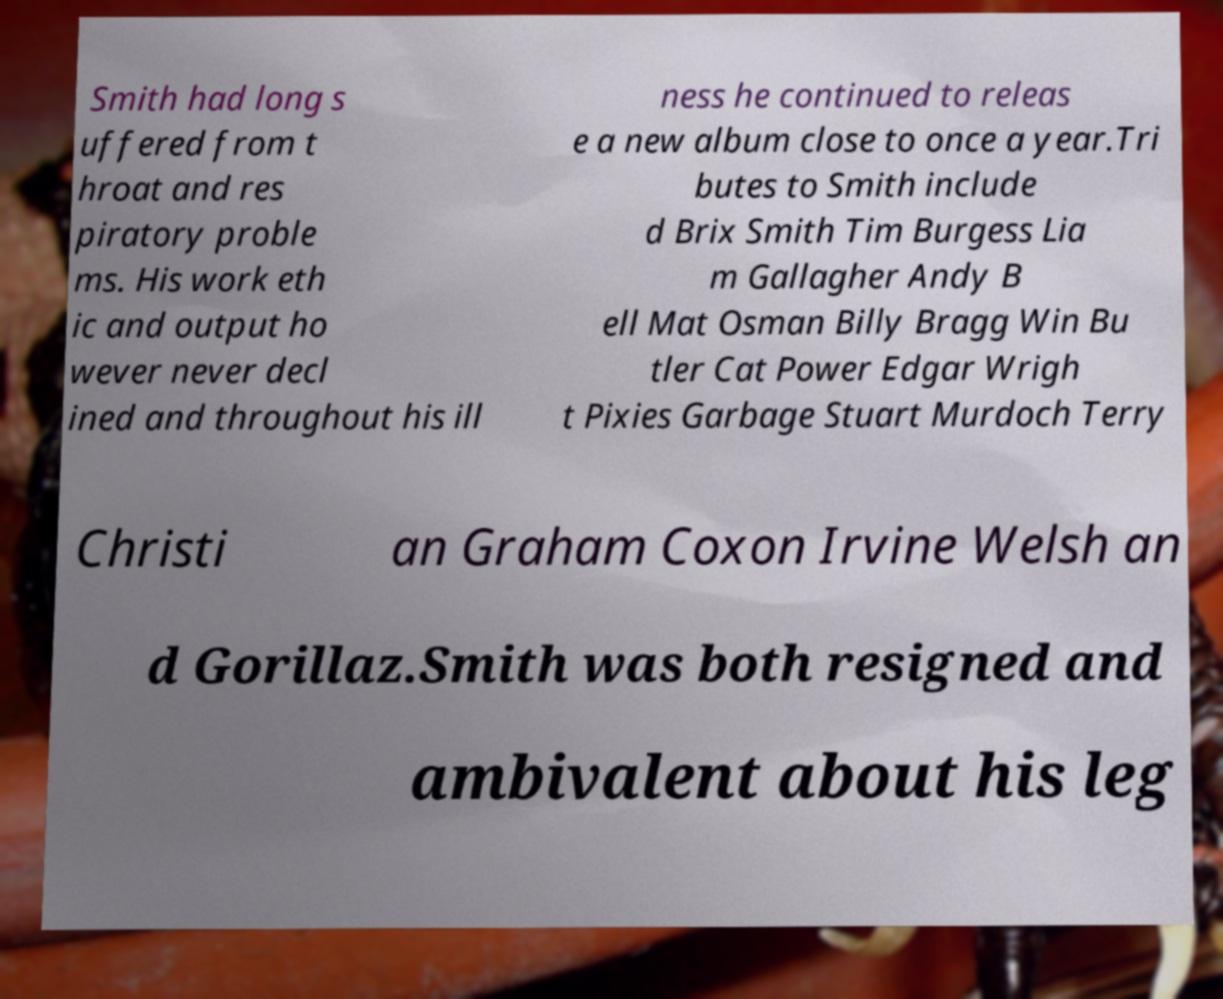For documentation purposes, I need the text within this image transcribed. Could you provide that? Smith had long s uffered from t hroat and res piratory proble ms. His work eth ic and output ho wever never decl ined and throughout his ill ness he continued to releas e a new album close to once a year.Tri butes to Smith include d Brix Smith Tim Burgess Lia m Gallagher Andy B ell Mat Osman Billy Bragg Win Bu tler Cat Power Edgar Wrigh t Pixies Garbage Stuart Murdoch Terry Christi an Graham Coxon Irvine Welsh an d Gorillaz.Smith was both resigned and ambivalent about his leg 